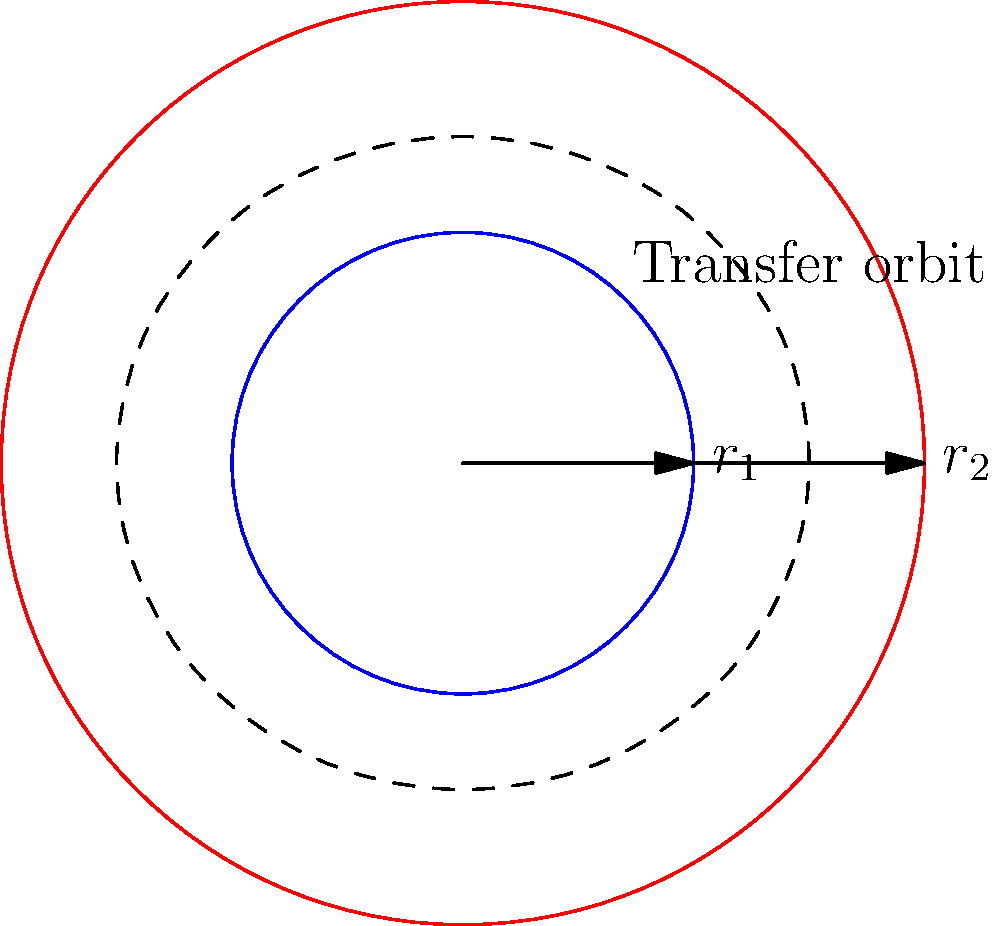Calculate the total delta-v required for a Hohmann transfer orbit between two circular orbits with radii $r_1 = 8000$ km and $r_2 = 42000$ km. Assume the gravitational parameter $\mu = 3.986 \times 10^{14}$ m³/s². Express your answer in km/s, rounded to two decimal places. To calculate the total delta-v for a Hohmann transfer orbit, we need to determine the velocity changes at the periapsis and apoapsis of the transfer orbit.

Step 1: Calculate the velocities of the initial and final circular orbits.
$v_1 = \sqrt{\frac{\mu}{r_1}} = \sqrt{\frac{3.986 \times 10^{14}}{8 \times 10^6}} = 7.057$ km/s
$v_2 = \sqrt{\frac{\mu}{r_2}} = \sqrt{\frac{3.986 \times 10^{14}}{42 \times 10^6}} = 3.075$ km/s

Step 2: Calculate the semi-major axis of the transfer orbit.
$a = \frac{r_1 + r_2}{2} = \frac{8000 + 42000}{2} = 25000$ km

Step 3: Calculate the velocities at periapsis and apoapsis of the transfer orbit.
$v_{p} = \sqrt{\mu(\frac{2}{r_1} - \frac{1}{a})} = \sqrt{3.986 \times 10^{14}(\frac{2}{8 \times 10^6} - \frac{1}{25 \times 10^6})} = 10.150$ km/s
$v_{a} = \sqrt{\mu(\frac{2}{r_2} - \frac{1}{a})} = \sqrt{3.986 \times 10^{14}(\frac{2}{42 \times 10^6} - \frac{1}{25 \times 10^6})} = 1.930$ km/s

Step 4: Calculate the delta-v at each burn.
$\Delta v_1 = v_{p} - v_1 = 10.150 - 7.057 = 3.093$ km/s
$\Delta v_2 = v_2 - v_{a} = 3.075 - 1.930 = 1.145$ km/s

Step 5: Calculate the total delta-v.
$\Delta v_{total} = \Delta v_1 + \Delta v_2 = 3.093 + 1.145 = 4.238$ km/s

Rounding to two decimal places: 4.24 km/s
Answer: 4.24 km/s 